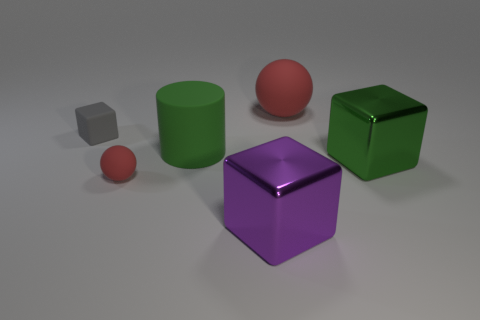What materials do these objects appear to be made from? The objects in the image appear to have different material properties. The objects are likely intended to represent materials such as rubber and plastic, noted by their various levels of reflectivity and the diffused way they scatter light. 